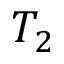Convert formula to latex. <formula><loc_0><loc_0><loc_500><loc_500>T _ { 2 }</formula> 